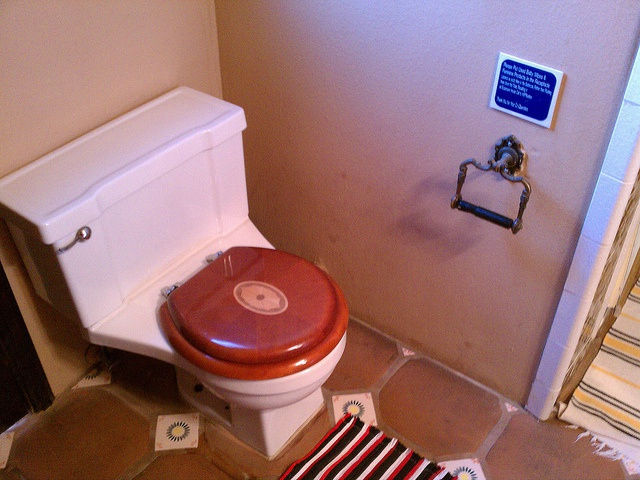Describe the objects in this image and their specific colors. I can see a toilet in gray, brown, maroon, and lightpink tones in this image. 